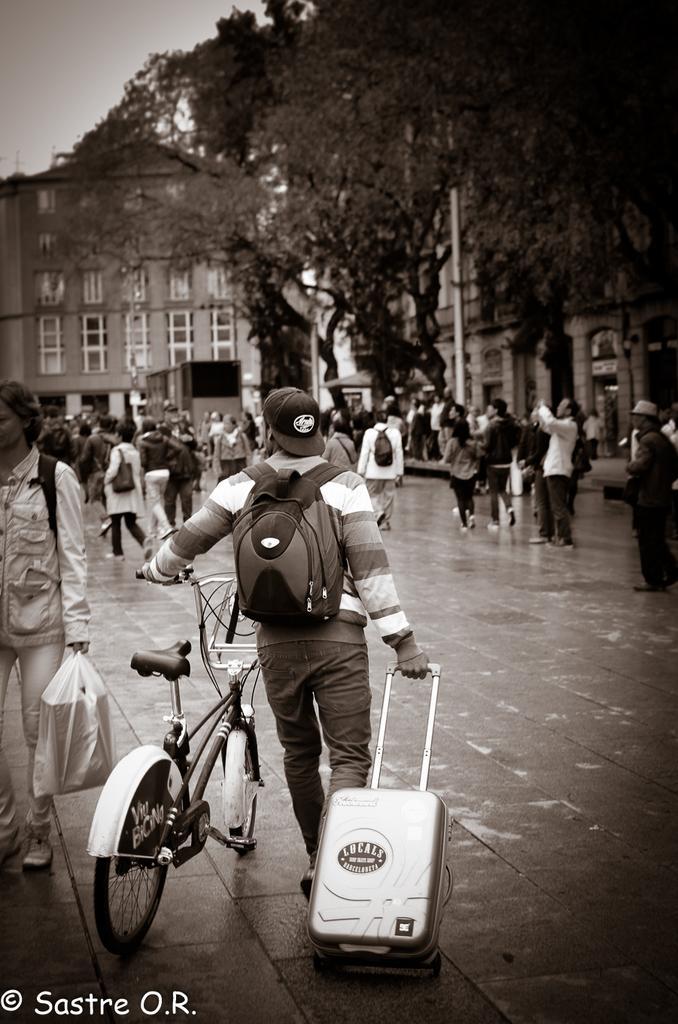Can you describe this image briefly? In the image we can see there is a man who is holding a trolley and bicycle in his hand and he is carrying a backpack and there are lot of people who are standing on the road and there are trees and building and it is a black and white image. 